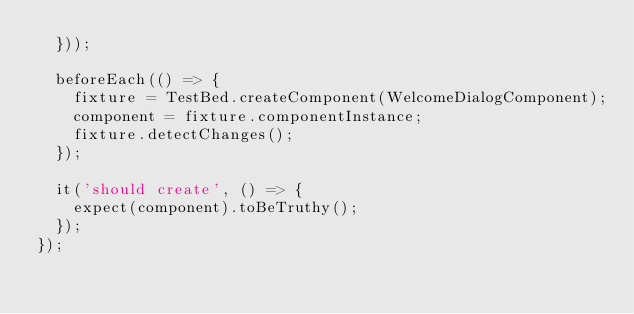<code> <loc_0><loc_0><loc_500><loc_500><_TypeScript_>  }));

  beforeEach(() => {
    fixture = TestBed.createComponent(WelcomeDialogComponent);
    component = fixture.componentInstance;
    fixture.detectChanges();
  });

  it('should create', () => {
    expect(component).toBeTruthy();
  });
});
</code> 